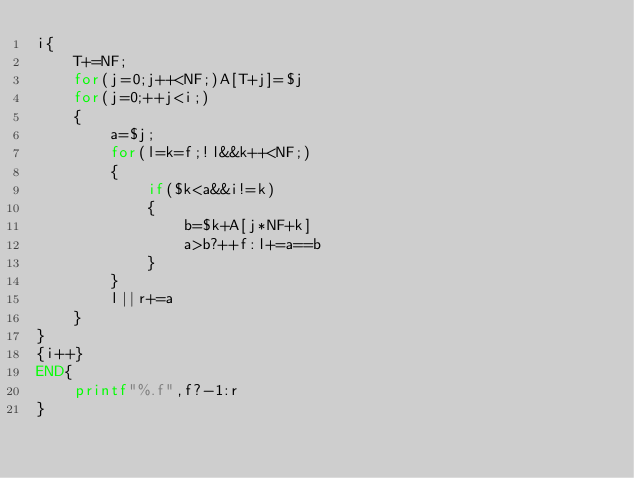Convert code to text. <code><loc_0><loc_0><loc_500><loc_500><_Awk_>i{
	T+=NF;
	for(j=0;j++<NF;)A[T+j]=$j
	for(j=0;++j<i;)
	{
		a=$j;
		for(l=k=f;!l&&k++<NF;)
		{
			if($k<a&&i!=k)
			{
				b=$k+A[j*NF+k]
				a>b?++f:l+=a==b
			}
		}
		l||r+=a
	}
}
{i++}
END{
	printf"%.f",f?-1:r
}</code> 